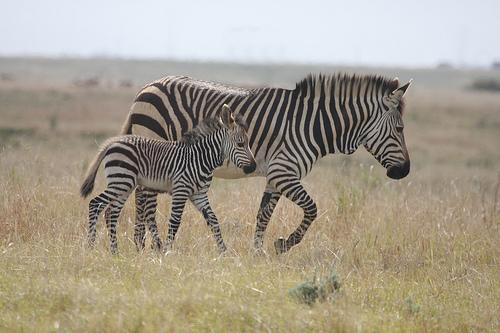How many zebras are shown?
Give a very brief answer. 2. How many baby zebras are shown?
Give a very brief answer. 1. 